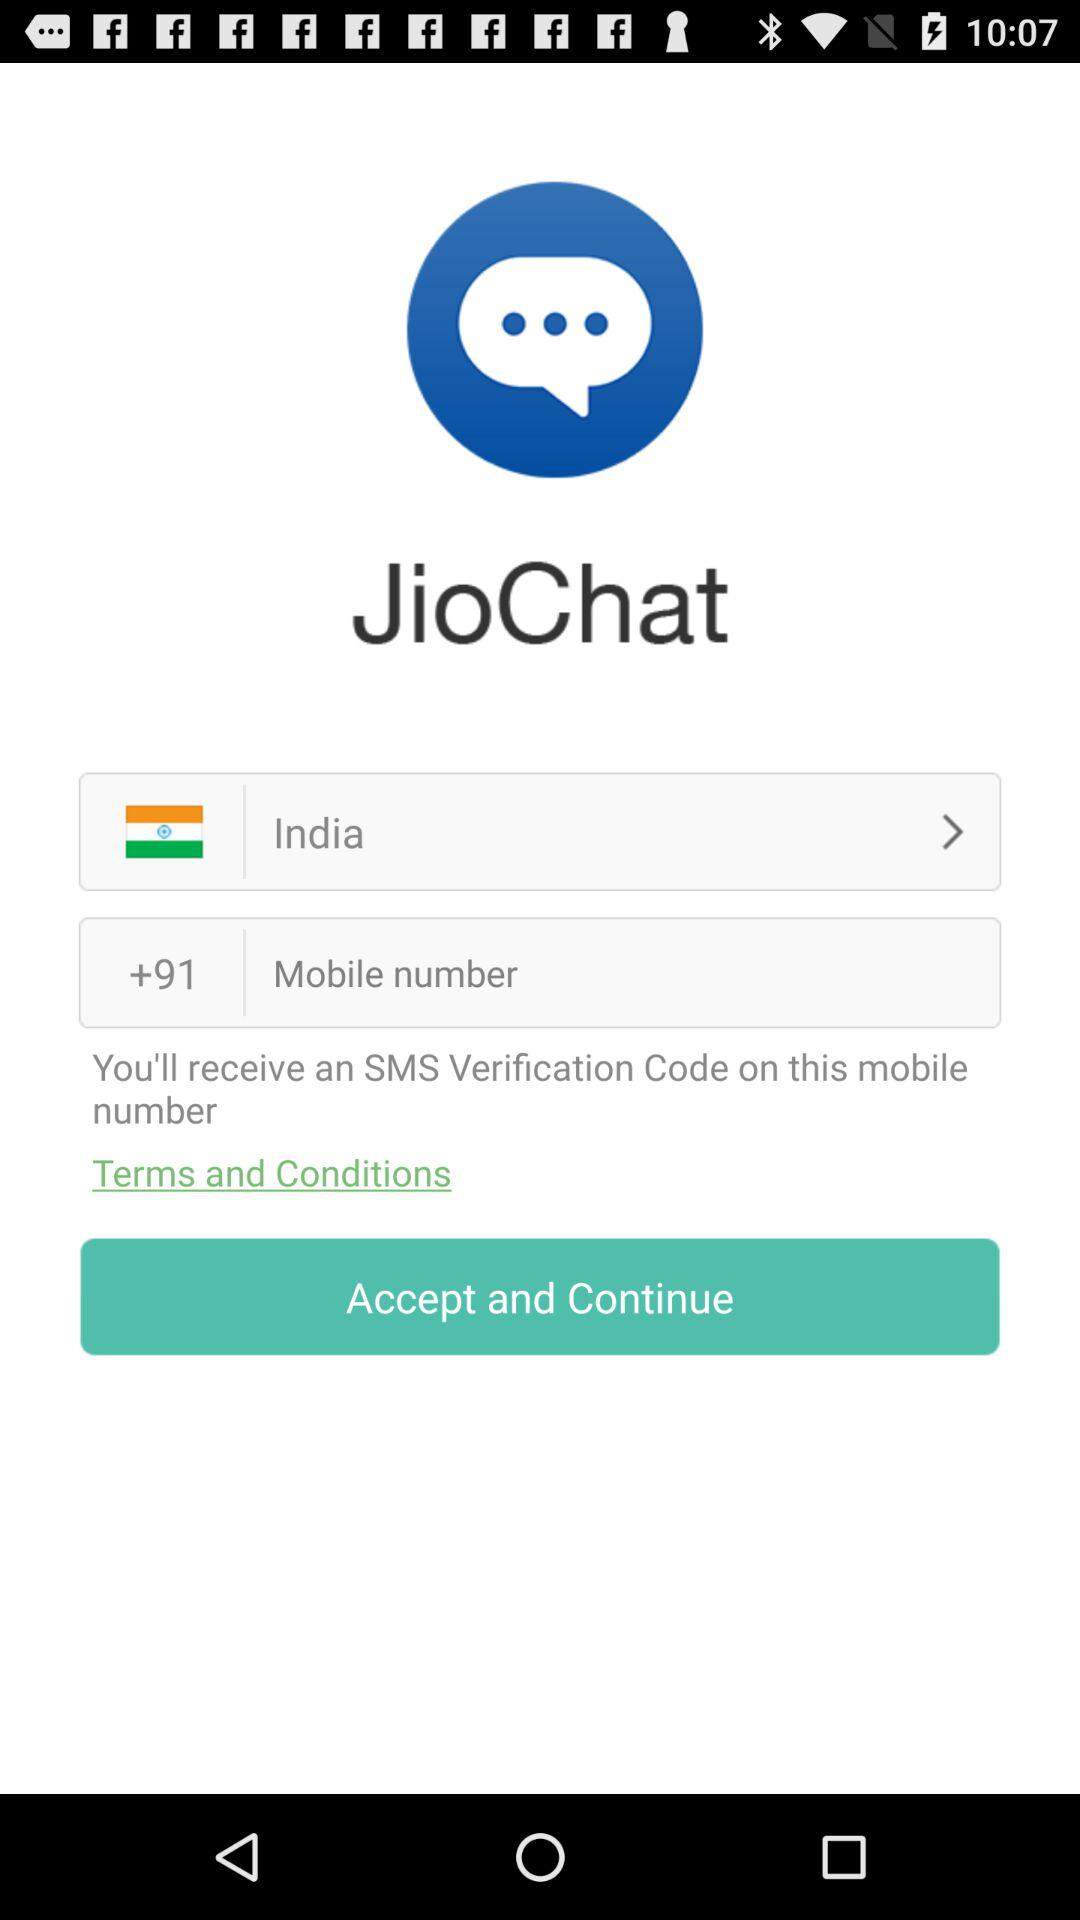Which country is selected? The selected country is "India". 